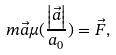Convert formula to latex. <formula><loc_0><loc_0><loc_500><loc_500>m \vec { a } \mu ( \frac { \left | \vec { a } \right | } { a _ { 0 } } ) = \vec { F } ,</formula> 